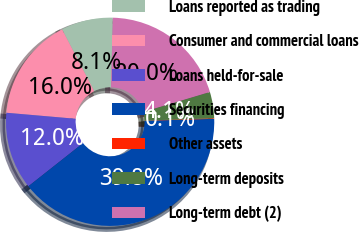Convert chart. <chart><loc_0><loc_0><loc_500><loc_500><pie_chart><fcel>Loans reported as trading<fcel>Consumer and commercial loans<fcel>Loans held-for-sale<fcel>Securities financing<fcel>Other assets<fcel>Long-term deposits<fcel>Long-term debt (2)<nl><fcel>8.05%<fcel>15.99%<fcel>12.02%<fcel>39.81%<fcel>0.1%<fcel>4.07%<fcel>19.96%<nl></chart> 